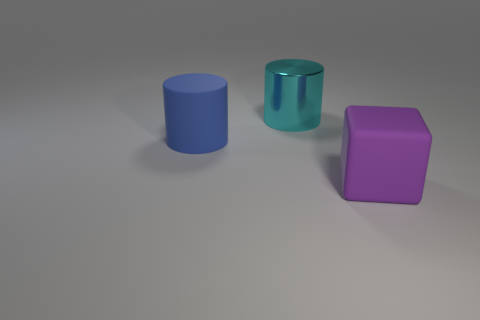Add 1 cyan shiny cylinders. How many objects exist? 4 Subtract all cylinders. How many objects are left? 1 Subtract all large metal cylinders. Subtract all purple cubes. How many objects are left? 1 Add 1 large purple blocks. How many large purple blocks are left? 2 Add 3 big cylinders. How many big cylinders exist? 5 Subtract 1 cyan cylinders. How many objects are left? 2 